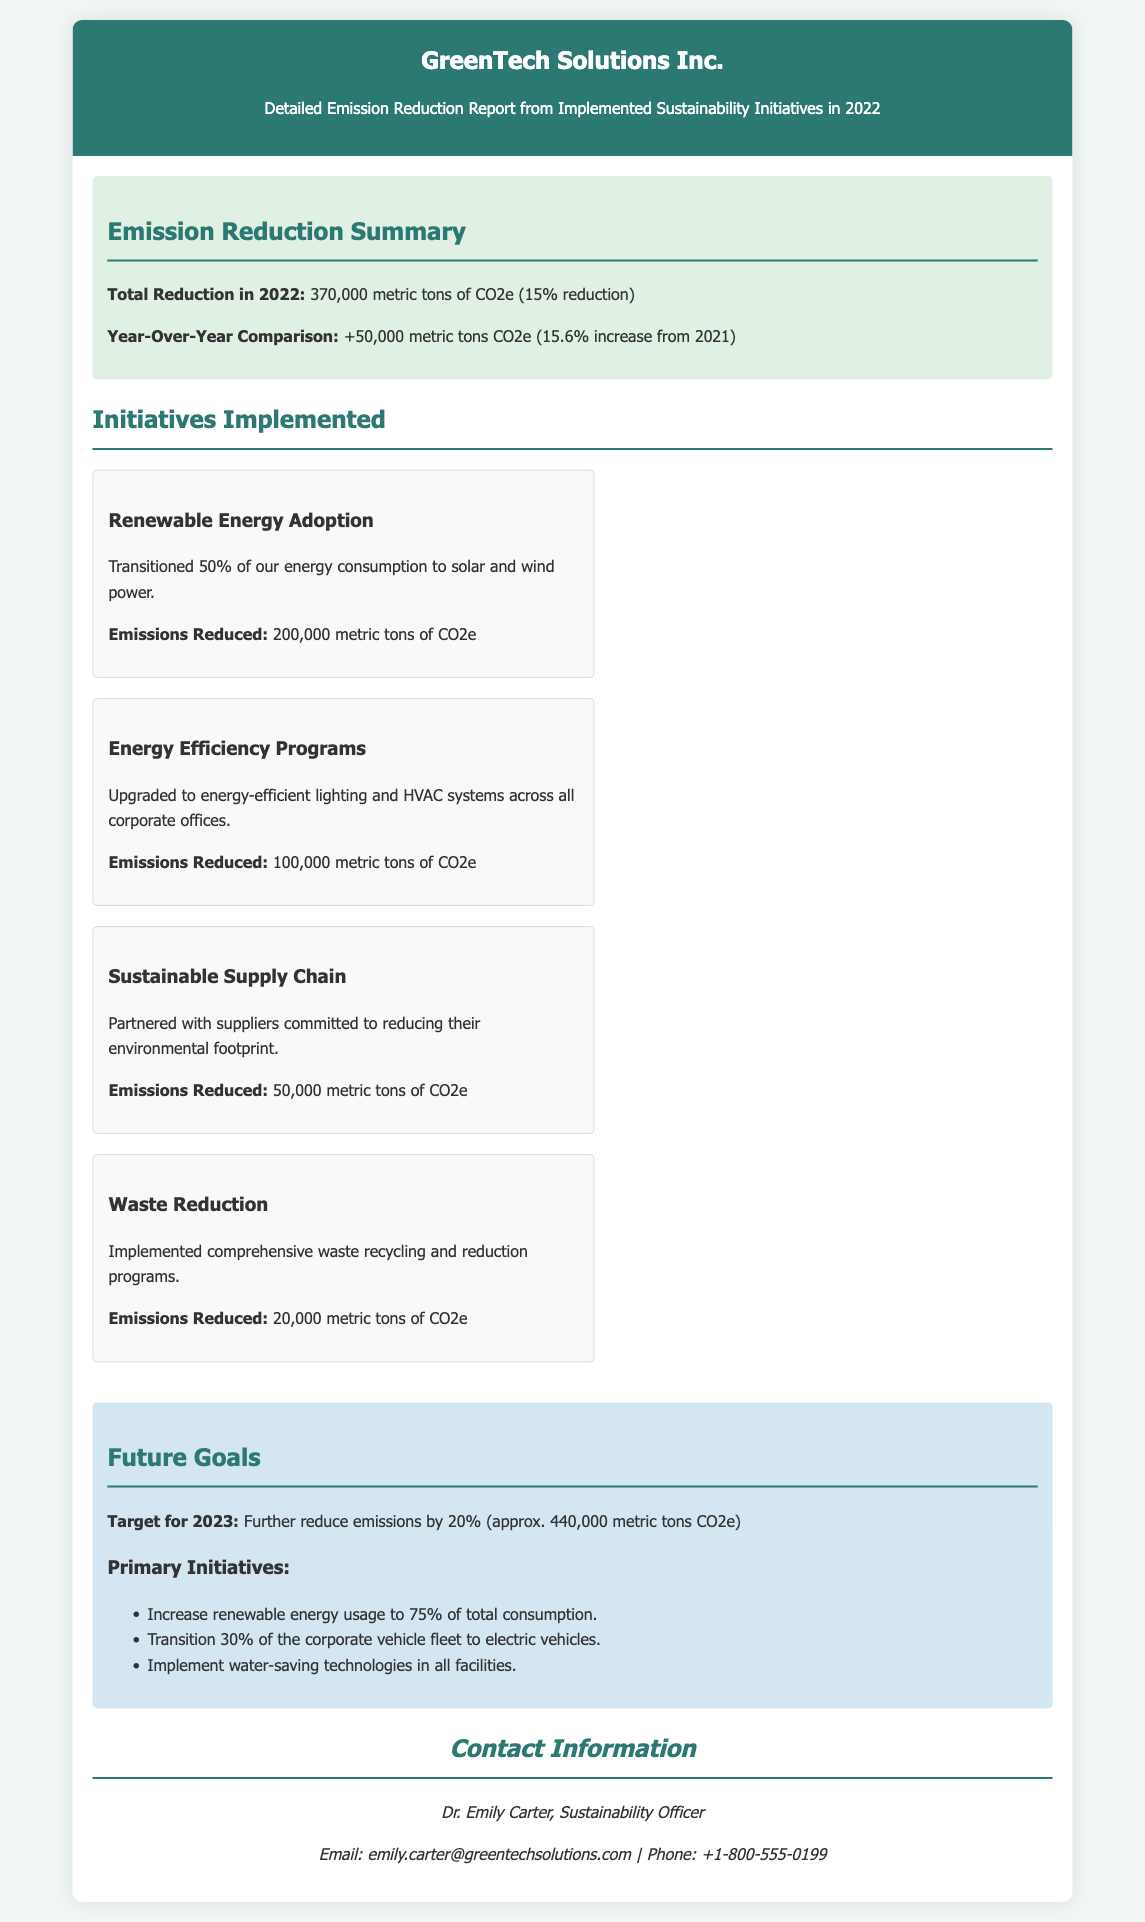What is the total reduction in 2022? The total reduction in 2022 is stated in the summary section of the document.
Answer: 370,000 metric tons of CO2e What was the year-over-year change from 2021? The year-over-year comparison is included in the summary section, providing the increase in emissions reduction.
Answer: +50,000 metric tons CO2e How many metric tons of CO2e were reduced by Renewable Energy Adoption? The emissions reduced from this initiative are detailed within the initiatives section.
Answer: 200,000 metric tons of CO2e What is the target emission reduction for 2023? The section detailing future goals specifies the target for the upcoming year.
Answer: 440,000 metric tons CO2e Who is the Sustainability Officer? The contact information section lists the name and title of the officer.
Answer: Dr. Emily Carter What percentage of total energy consumption was transitioned to renewable energy? This information is provided in the description of the Renewable Energy Adoption initiative.
Answer: 50% What is one of the primary initiatives for 2023? The future goals section lists several initiatives aimed at reducing emissions further.
Answer: Increase renewable energy usage to 75% What was the emissions reduction from the Waste Reduction initiative? The specific emissions reduced by this initiative can be found in the initiatives section.
Answer: 20,000 metric tons of CO2e What color scheme is used for the header of the document? The document specifies the color of the header, which can be observed in the rendered view.
Answer: Dark green 